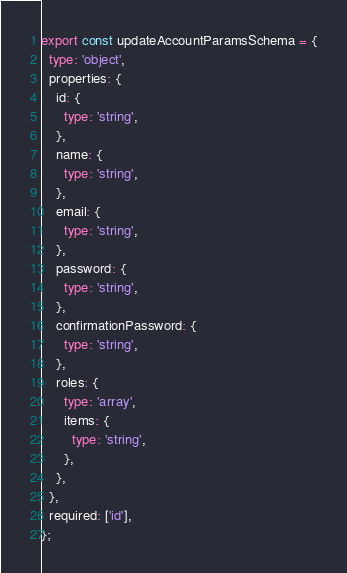<code> <loc_0><loc_0><loc_500><loc_500><_TypeScript_>export const updateAccountParamsSchema = {
  type: 'object',
  properties: {
    id: {
      type: 'string',
    },
    name: {
      type: 'string',
    },
    email: {
      type: 'string',
    },
    password: {
      type: 'string',
    },
    confirmationPassword: {
      type: 'string',
    },
    roles: {
      type: 'array',
      items: {
        type: 'string',
      },
    },
  },
  required: ['id'],
};
</code> 